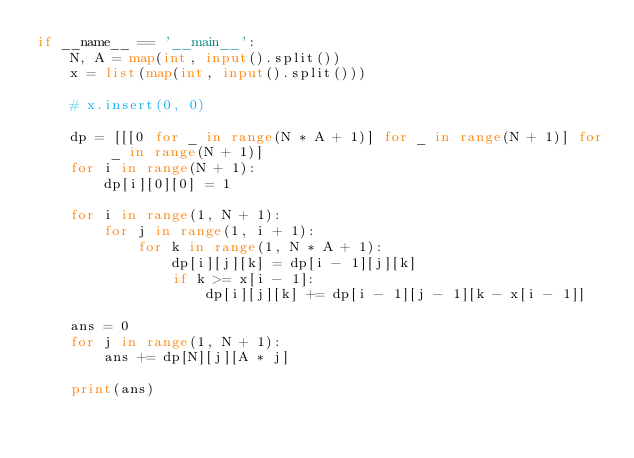<code> <loc_0><loc_0><loc_500><loc_500><_Python_>if __name__ == '__main__':
    N, A = map(int, input().split())
    x = list(map(int, input().split()))

    # x.insert(0, 0)

    dp = [[[0 for _ in range(N * A + 1)] for _ in range(N + 1)] for _ in range(N + 1)]
    for i in range(N + 1):
        dp[i][0][0] = 1

    for i in range(1, N + 1):
        for j in range(1, i + 1):
            for k in range(1, N * A + 1):
                dp[i][j][k] = dp[i - 1][j][k]
                if k >= x[i - 1]:
                    dp[i][j][k] += dp[i - 1][j - 1][k - x[i - 1]]

    ans = 0
    for j in range(1, N + 1):
        ans += dp[N][j][A * j]

    print(ans)
</code> 